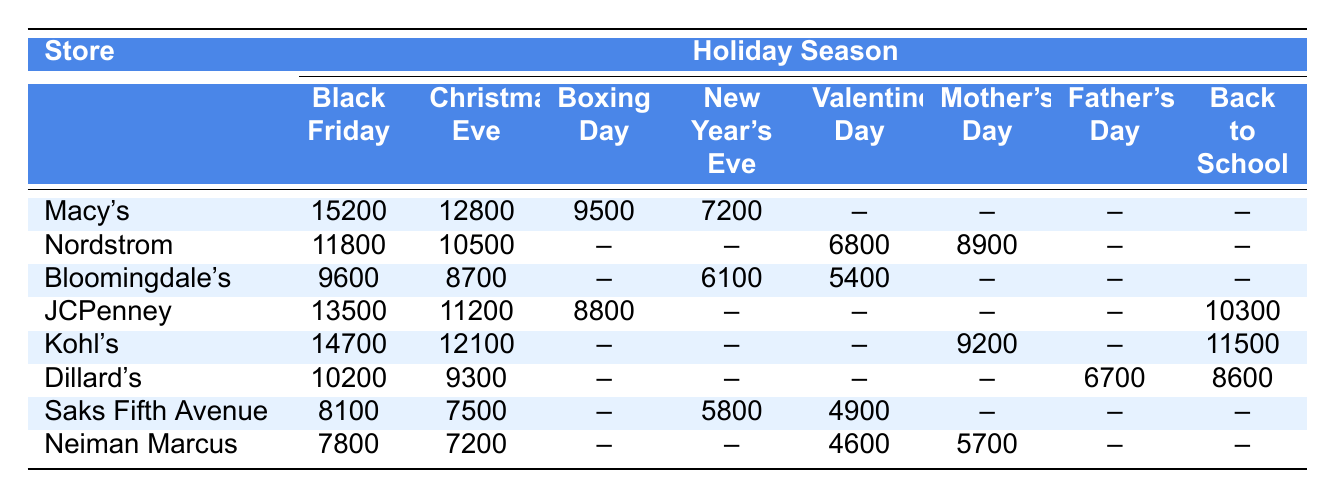What store had the highest foot traffic on Black Friday? From the table, Macy's has the highest foot traffic on Black Friday with a total of 15,200 customers.
Answer: Macy's What is the foot traffic for Dillard's on Christmas Eve? According to the table, Dillard's had 9,300 customers on Christmas Eve.
Answer: 9,300 Which store had the least foot traffic on New Year's Eve? On New Year's Eve, Neiman Marcus had the least foot traffic with 7,200 customers.
Answer: Neiman Marcus How many customers visited JCPenney on Boxing Day? The table indicates that JCPenney had 8,800 customers on Boxing Day.
Answer: 8,800 What is the total foot traffic for Kohl's across all recorded holiday seasons? The total foot traffic for Kohl's is calculated by adding all the values: 14,700 + 12,100 + 9,200 + 11,500 = 47,500.
Answer: 47,500 Did Saks Fifth Avenue have more customers on New Year's Eve than on Christmas Eve? Saks Fifth Avenue had 5,800 customers on New Year's Eve and 7,500 on Christmas Eve, so it had fewer customers on New Year's Eve.
Answer: No What was the average foot traffic for all stores on Black Friday? To find the average, sum the values for Black Friday: 15,200 + 11,800 + 9,600 + 13,500 + 14,700 + 10,200 + 8,100 + 7,800 = 90,900. There are 8 stores, thus the average is 90,900 / 8 = 11,362.5.
Answer: 11,362.5 Which holiday season had the highest total foot traffic across all stores? Summing each holiday's foot traffic, Black Friday totals 90,900, Christmas Eve totals 83,600, Boxing Day totals 22,300, New Year's Eve totals 32,800, Valentine’s Day totals 13,000, Mother’s Day totals 15,800, Father’s Day totals 6,700, and Back to School totals 36,800. Black Friday has the highest total foot traffic.
Answer: Black Friday Which store saw the highest increase in foot traffic from Valentine's Day to Mother's Day? Only Nordstrom and Kohl's have observations for both holidays. Nordstrom had 6,800 on Valentine's and 8,900 on Mother's Day ((8,900 - 6,800) = 2,100), while Kohl's had no value for Valentine's Day. Thus, Nordstrom saw the highest increase.
Answer: Nordstrom How does the foot traffic of Macy's on Christmas Eve compare to their performance on Black Friday? Macy's had 12,800 customers on Christmas Eve and 15,200 on Black Friday. The difference is 15,200 - 12,800 = 2,400, showing that Black Friday saw more customers than Christmas Eve for Macy's.
Answer: More customers on Black Friday by 2,400 